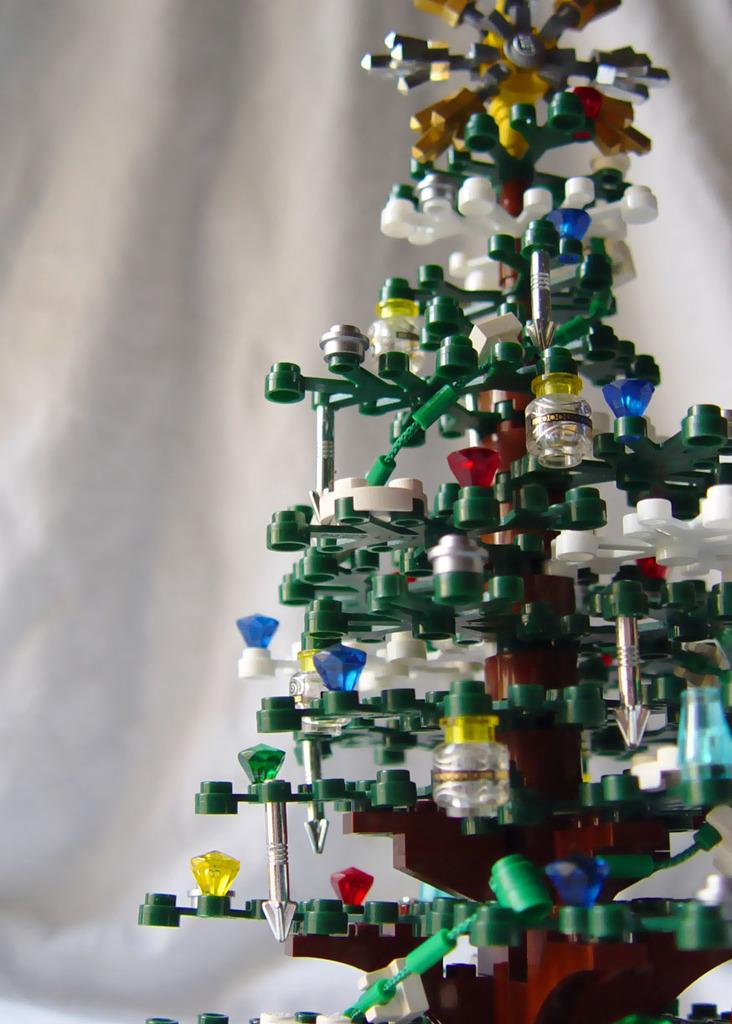What type of tree is featured in the image? There is a decorative Christmas tree in the image. What color is the background of the image? The background of the image is white. What type of amusement can be seen in the image? There is no amusement present in the image; it features a decorative Christmas tree and a white background. Can you tell me how many copies of the Christmas tree are visible in the image? There is only one Christmas tree visible in the image. 